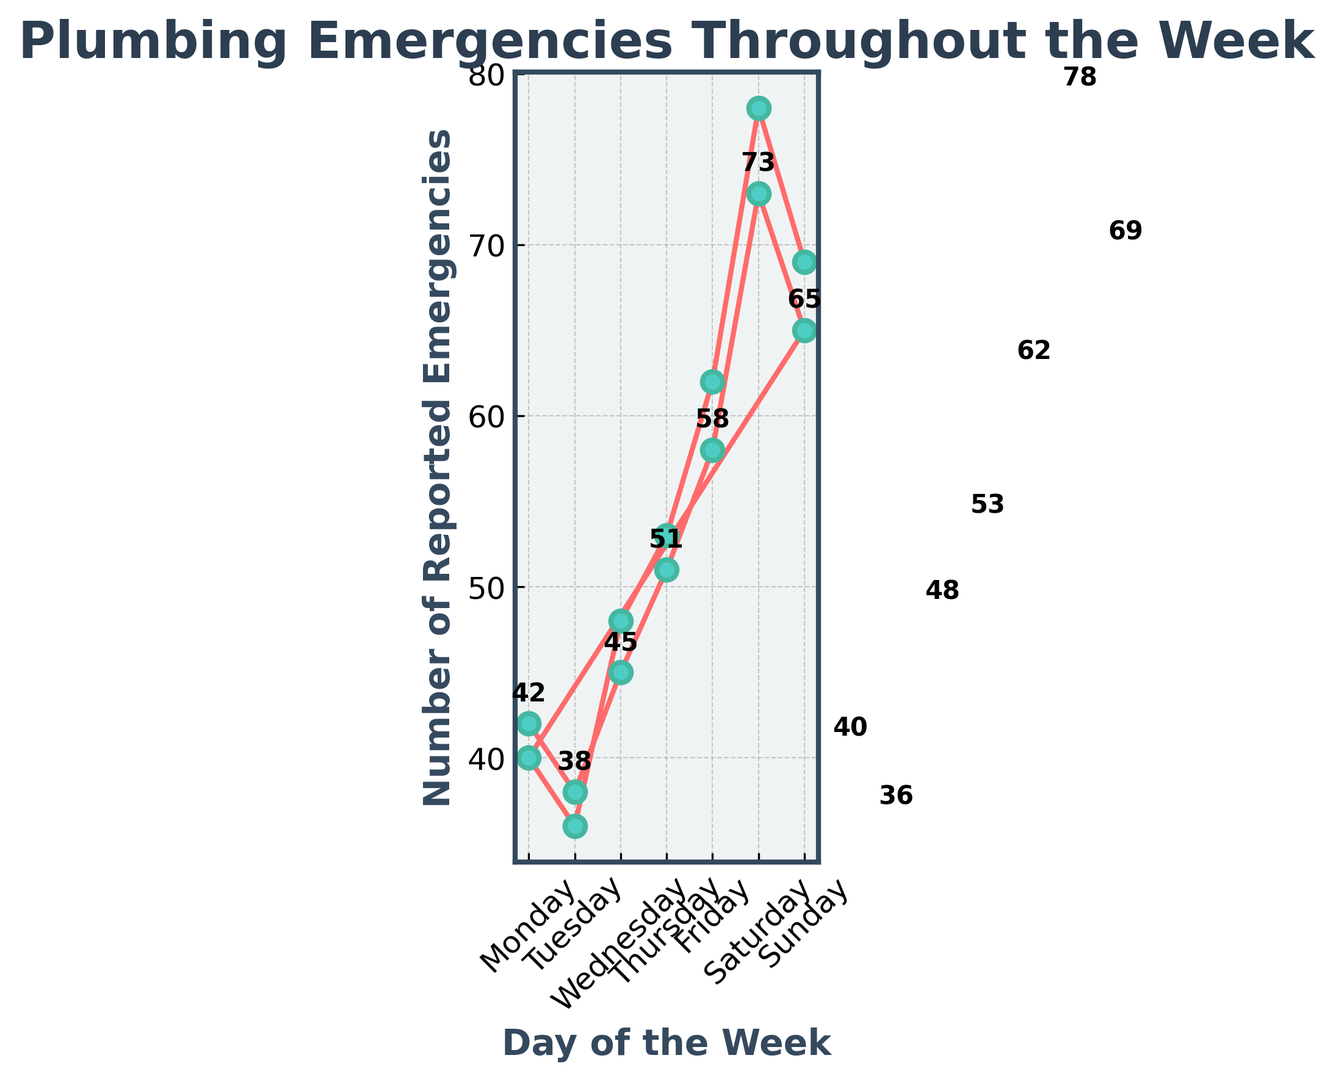What is the highest number of reported plumbing emergencies in a single day? Look for the highest point on the line graph. The highest value is observed on the second Saturday at 78 reported emergencies.
Answer: 78 Which day shows a decrease in reported emergencies from the previous day? Identify the days where the line descends from the previous day. Wednesday to Thursday in the first week shows no decrease, but Monday to Tuesday in the second week does. Also, Sunday to Monday in the second week.
Answer: Tuesday, Monday What is the difference in the number of reported emergencies between the two Sundays? Compare the values on both Sundays. First Sunday has 65 reported emergencies and the second Sunday has 69. The difference is 69 - 65 = 4.
Answer: 4 Which day of the week shows the most consistent number of reported emergencies across the two weeks? Look for a day that has similar values in both weeks. Monday shows 42 and 40, with a difference of only 2, which seems to be the most consistent.
Answer: Monday How does the number of reported emergencies on the first Wednesday compare to the second Wednesday? Compare the reported emergencies on these two days: 45 and 48. The second Wednesday has 3 more reported emergencies than the first Wednesday.
Answer: Second Wednesday is higher On which day does the first significant increase in reported emergencies appear? Look for the first steep incline in the line graph. The first noticeable increase is observed from Thursday to Friday in the first week, from 51 to 58.
Answer: Friday What is the average number of reported plumbing emergencies over the two Sundays? Calculate the average of the two values for Sundays: (65 + 69) / 2 = 67.
Answer: 67 Is there a pattern in emergency reporting from Monday to Sunday? Observe the trend through two weeks. Generally, there is a gradual increase beginning midweek, peaking on Saturday and then slightly dropping on Sunday.
Answer: General increase to Saturday, slight drop on Sunday What is the range of reported emergencies on Saturdays? Identify the max and min values on Saturdays. The values are 73 and 78. The range is 78 - 73 = 5.
Answer: 5 Which week had a higher total number of reported plumbing emergencies? Sum the values for each week. First week: 42 + 38 + 45 + 51 + 58 + 73 + 65 = 372. Second week: 40 + 36 + 48 + 53 + 62 + 78 + 69 = 386. The second week is higher.
Answer: Second week 